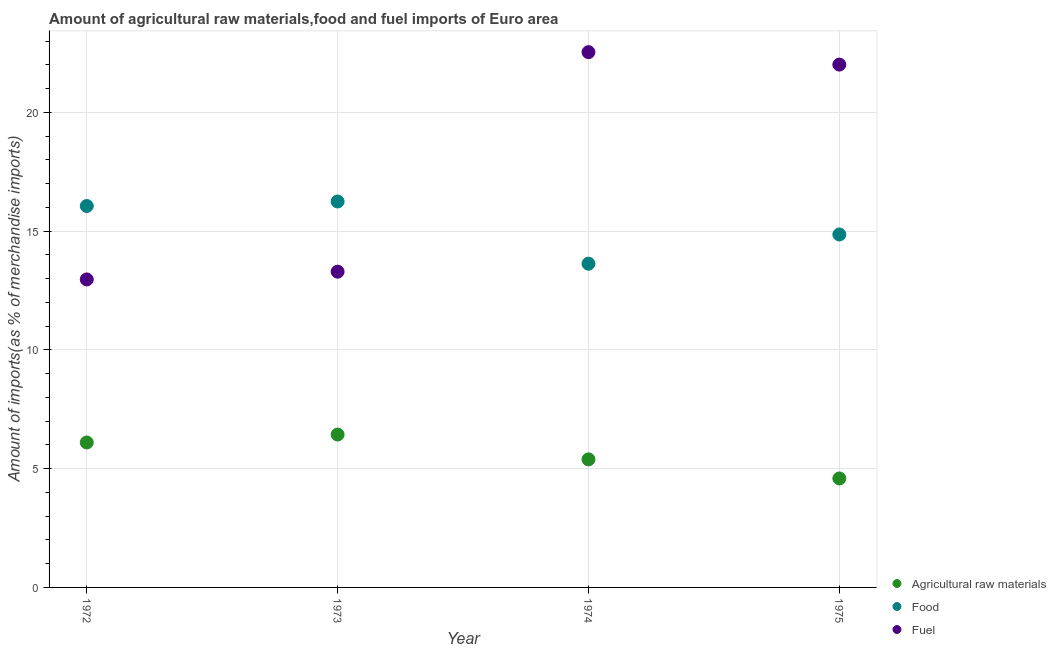How many different coloured dotlines are there?
Make the answer very short. 3. Is the number of dotlines equal to the number of legend labels?
Make the answer very short. Yes. What is the percentage of raw materials imports in 1973?
Provide a short and direct response. 6.44. Across all years, what is the maximum percentage of food imports?
Offer a terse response. 16.25. Across all years, what is the minimum percentage of raw materials imports?
Provide a succinct answer. 4.59. In which year was the percentage of food imports maximum?
Give a very brief answer. 1973. In which year was the percentage of raw materials imports minimum?
Offer a very short reply. 1975. What is the total percentage of raw materials imports in the graph?
Make the answer very short. 22.51. What is the difference between the percentage of food imports in 1972 and that in 1973?
Your answer should be very brief. -0.19. What is the difference between the percentage of raw materials imports in 1975 and the percentage of food imports in 1973?
Your answer should be compact. -11.66. What is the average percentage of food imports per year?
Keep it short and to the point. 15.2. In the year 1972, what is the difference between the percentage of food imports and percentage of fuel imports?
Provide a short and direct response. 3.09. In how many years, is the percentage of raw materials imports greater than 19 %?
Keep it short and to the point. 0. What is the ratio of the percentage of raw materials imports in 1972 to that in 1973?
Offer a terse response. 0.95. Is the percentage of raw materials imports in 1972 less than that in 1974?
Your answer should be very brief. No. Is the difference between the percentage of raw materials imports in 1972 and 1975 greater than the difference between the percentage of food imports in 1972 and 1975?
Your answer should be very brief. Yes. What is the difference between the highest and the second highest percentage of fuel imports?
Give a very brief answer. 0.52. What is the difference between the highest and the lowest percentage of food imports?
Keep it short and to the point. 2.62. Does the percentage of food imports monotonically increase over the years?
Your answer should be compact. No. Is the percentage of raw materials imports strictly greater than the percentage of food imports over the years?
Give a very brief answer. No. Is the percentage of raw materials imports strictly less than the percentage of fuel imports over the years?
Offer a terse response. Yes. Are the values on the major ticks of Y-axis written in scientific E-notation?
Offer a terse response. No. What is the title of the graph?
Keep it short and to the point. Amount of agricultural raw materials,food and fuel imports of Euro area. Does "Coal" appear as one of the legend labels in the graph?
Ensure brevity in your answer.  No. What is the label or title of the X-axis?
Make the answer very short. Year. What is the label or title of the Y-axis?
Provide a short and direct response. Amount of imports(as % of merchandise imports). What is the Amount of imports(as % of merchandise imports) of Agricultural raw materials in 1972?
Provide a succinct answer. 6.1. What is the Amount of imports(as % of merchandise imports) in Food in 1972?
Your answer should be compact. 16.05. What is the Amount of imports(as % of merchandise imports) of Fuel in 1972?
Offer a very short reply. 12.96. What is the Amount of imports(as % of merchandise imports) of Agricultural raw materials in 1973?
Ensure brevity in your answer.  6.44. What is the Amount of imports(as % of merchandise imports) in Food in 1973?
Give a very brief answer. 16.25. What is the Amount of imports(as % of merchandise imports) of Fuel in 1973?
Your response must be concise. 13.29. What is the Amount of imports(as % of merchandise imports) in Agricultural raw materials in 1974?
Provide a short and direct response. 5.39. What is the Amount of imports(as % of merchandise imports) of Food in 1974?
Your answer should be compact. 13.63. What is the Amount of imports(as % of merchandise imports) of Fuel in 1974?
Make the answer very short. 22.53. What is the Amount of imports(as % of merchandise imports) in Agricultural raw materials in 1975?
Offer a very short reply. 4.59. What is the Amount of imports(as % of merchandise imports) in Food in 1975?
Your answer should be compact. 14.86. What is the Amount of imports(as % of merchandise imports) in Fuel in 1975?
Your answer should be compact. 22.01. Across all years, what is the maximum Amount of imports(as % of merchandise imports) of Agricultural raw materials?
Your answer should be very brief. 6.44. Across all years, what is the maximum Amount of imports(as % of merchandise imports) in Food?
Your answer should be compact. 16.25. Across all years, what is the maximum Amount of imports(as % of merchandise imports) in Fuel?
Keep it short and to the point. 22.53. Across all years, what is the minimum Amount of imports(as % of merchandise imports) of Agricultural raw materials?
Give a very brief answer. 4.59. Across all years, what is the minimum Amount of imports(as % of merchandise imports) in Food?
Provide a short and direct response. 13.63. Across all years, what is the minimum Amount of imports(as % of merchandise imports) of Fuel?
Your answer should be very brief. 12.96. What is the total Amount of imports(as % of merchandise imports) of Agricultural raw materials in the graph?
Your answer should be compact. 22.51. What is the total Amount of imports(as % of merchandise imports) in Food in the graph?
Your answer should be compact. 60.78. What is the total Amount of imports(as % of merchandise imports) of Fuel in the graph?
Make the answer very short. 70.79. What is the difference between the Amount of imports(as % of merchandise imports) in Agricultural raw materials in 1972 and that in 1973?
Make the answer very short. -0.33. What is the difference between the Amount of imports(as % of merchandise imports) of Food in 1972 and that in 1973?
Give a very brief answer. -0.19. What is the difference between the Amount of imports(as % of merchandise imports) of Fuel in 1972 and that in 1973?
Your response must be concise. -0.33. What is the difference between the Amount of imports(as % of merchandise imports) of Agricultural raw materials in 1972 and that in 1974?
Offer a very short reply. 0.71. What is the difference between the Amount of imports(as % of merchandise imports) of Food in 1972 and that in 1974?
Offer a very short reply. 2.43. What is the difference between the Amount of imports(as % of merchandise imports) in Fuel in 1972 and that in 1974?
Your answer should be compact. -9.57. What is the difference between the Amount of imports(as % of merchandise imports) in Agricultural raw materials in 1972 and that in 1975?
Make the answer very short. 1.51. What is the difference between the Amount of imports(as % of merchandise imports) in Food in 1972 and that in 1975?
Offer a terse response. 1.2. What is the difference between the Amount of imports(as % of merchandise imports) in Fuel in 1972 and that in 1975?
Make the answer very short. -9.04. What is the difference between the Amount of imports(as % of merchandise imports) of Agricultural raw materials in 1973 and that in 1974?
Give a very brief answer. 1.04. What is the difference between the Amount of imports(as % of merchandise imports) of Food in 1973 and that in 1974?
Make the answer very short. 2.62. What is the difference between the Amount of imports(as % of merchandise imports) of Fuel in 1973 and that in 1974?
Make the answer very short. -9.24. What is the difference between the Amount of imports(as % of merchandise imports) in Agricultural raw materials in 1973 and that in 1975?
Offer a very short reply. 1.85. What is the difference between the Amount of imports(as % of merchandise imports) in Food in 1973 and that in 1975?
Provide a short and direct response. 1.39. What is the difference between the Amount of imports(as % of merchandise imports) of Fuel in 1973 and that in 1975?
Your response must be concise. -8.72. What is the difference between the Amount of imports(as % of merchandise imports) of Agricultural raw materials in 1974 and that in 1975?
Make the answer very short. 0.8. What is the difference between the Amount of imports(as % of merchandise imports) in Food in 1974 and that in 1975?
Give a very brief answer. -1.23. What is the difference between the Amount of imports(as % of merchandise imports) of Fuel in 1974 and that in 1975?
Give a very brief answer. 0.52. What is the difference between the Amount of imports(as % of merchandise imports) in Agricultural raw materials in 1972 and the Amount of imports(as % of merchandise imports) in Food in 1973?
Keep it short and to the point. -10.14. What is the difference between the Amount of imports(as % of merchandise imports) in Agricultural raw materials in 1972 and the Amount of imports(as % of merchandise imports) in Fuel in 1973?
Ensure brevity in your answer.  -7.19. What is the difference between the Amount of imports(as % of merchandise imports) of Food in 1972 and the Amount of imports(as % of merchandise imports) of Fuel in 1973?
Your answer should be very brief. 2.76. What is the difference between the Amount of imports(as % of merchandise imports) in Agricultural raw materials in 1972 and the Amount of imports(as % of merchandise imports) in Food in 1974?
Provide a succinct answer. -7.52. What is the difference between the Amount of imports(as % of merchandise imports) in Agricultural raw materials in 1972 and the Amount of imports(as % of merchandise imports) in Fuel in 1974?
Your answer should be very brief. -16.43. What is the difference between the Amount of imports(as % of merchandise imports) in Food in 1972 and the Amount of imports(as % of merchandise imports) in Fuel in 1974?
Offer a very short reply. -6.48. What is the difference between the Amount of imports(as % of merchandise imports) of Agricultural raw materials in 1972 and the Amount of imports(as % of merchandise imports) of Food in 1975?
Your answer should be very brief. -8.76. What is the difference between the Amount of imports(as % of merchandise imports) of Agricultural raw materials in 1972 and the Amount of imports(as % of merchandise imports) of Fuel in 1975?
Give a very brief answer. -15.91. What is the difference between the Amount of imports(as % of merchandise imports) in Food in 1972 and the Amount of imports(as % of merchandise imports) in Fuel in 1975?
Give a very brief answer. -5.95. What is the difference between the Amount of imports(as % of merchandise imports) in Agricultural raw materials in 1973 and the Amount of imports(as % of merchandise imports) in Food in 1974?
Your answer should be compact. -7.19. What is the difference between the Amount of imports(as % of merchandise imports) in Agricultural raw materials in 1973 and the Amount of imports(as % of merchandise imports) in Fuel in 1974?
Give a very brief answer. -16.1. What is the difference between the Amount of imports(as % of merchandise imports) of Food in 1973 and the Amount of imports(as % of merchandise imports) of Fuel in 1974?
Offer a very short reply. -6.29. What is the difference between the Amount of imports(as % of merchandise imports) of Agricultural raw materials in 1973 and the Amount of imports(as % of merchandise imports) of Food in 1975?
Give a very brief answer. -8.42. What is the difference between the Amount of imports(as % of merchandise imports) in Agricultural raw materials in 1973 and the Amount of imports(as % of merchandise imports) in Fuel in 1975?
Your answer should be very brief. -15.57. What is the difference between the Amount of imports(as % of merchandise imports) in Food in 1973 and the Amount of imports(as % of merchandise imports) in Fuel in 1975?
Provide a succinct answer. -5.76. What is the difference between the Amount of imports(as % of merchandise imports) of Agricultural raw materials in 1974 and the Amount of imports(as % of merchandise imports) of Food in 1975?
Provide a short and direct response. -9.47. What is the difference between the Amount of imports(as % of merchandise imports) in Agricultural raw materials in 1974 and the Amount of imports(as % of merchandise imports) in Fuel in 1975?
Offer a very short reply. -16.62. What is the difference between the Amount of imports(as % of merchandise imports) in Food in 1974 and the Amount of imports(as % of merchandise imports) in Fuel in 1975?
Provide a short and direct response. -8.38. What is the average Amount of imports(as % of merchandise imports) of Agricultural raw materials per year?
Offer a terse response. 5.63. What is the average Amount of imports(as % of merchandise imports) of Food per year?
Offer a terse response. 15.2. What is the average Amount of imports(as % of merchandise imports) of Fuel per year?
Make the answer very short. 17.7. In the year 1972, what is the difference between the Amount of imports(as % of merchandise imports) in Agricultural raw materials and Amount of imports(as % of merchandise imports) in Food?
Provide a succinct answer. -9.95. In the year 1972, what is the difference between the Amount of imports(as % of merchandise imports) in Agricultural raw materials and Amount of imports(as % of merchandise imports) in Fuel?
Ensure brevity in your answer.  -6.86. In the year 1972, what is the difference between the Amount of imports(as % of merchandise imports) in Food and Amount of imports(as % of merchandise imports) in Fuel?
Provide a succinct answer. 3.09. In the year 1973, what is the difference between the Amount of imports(as % of merchandise imports) in Agricultural raw materials and Amount of imports(as % of merchandise imports) in Food?
Your response must be concise. -9.81. In the year 1973, what is the difference between the Amount of imports(as % of merchandise imports) of Agricultural raw materials and Amount of imports(as % of merchandise imports) of Fuel?
Offer a very short reply. -6.86. In the year 1973, what is the difference between the Amount of imports(as % of merchandise imports) of Food and Amount of imports(as % of merchandise imports) of Fuel?
Provide a succinct answer. 2.95. In the year 1974, what is the difference between the Amount of imports(as % of merchandise imports) of Agricultural raw materials and Amount of imports(as % of merchandise imports) of Food?
Keep it short and to the point. -8.24. In the year 1974, what is the difference between the Amount of imports(as % of merchandise imports) of Agricultural raw materials and Amount of imports(as % of merchandise imports) of Fuel?
Ensure brevity in your answer.  -17.14. In the year 1974, what is the difference between the Amount of imports(as % of merchandise imports) of Food and Amount of imports(as % of merchandise imports) of Fuel?
Provide a succinct answer. -8.91. In the year 1975, what is the difference between the Amount of imports(as % of merchandise imports) of Agricultural raw materials and Amount of imports(as % of merchandise imports) of Food?
Your answer should be compact. -10.27. In the year 1975, what is the difference between the Amount of imports(as % of merchandise imports) of Agricultural raw materials and Amount of imports(as % of merchandise imports) of Fuel?
Your answer should be compact. -17.42. In the year 1975, what is the difference between the Amount of imports(as % of merchandise imports) in Food and Amount of imports(as % of merchandise imports) in Fuel?
Make the answer very short. -7.15. What is the ratio of the Amount of imports(as % of merchandise imports) of Agricultural raw materials in 1972 to that in 1973?
Provide a short and direct response. 0.95. What is the ratio of the Amount of imports(as % of merchandise imports) in Food in 1972 to that in 1973?
Ensure brevity in your answer.  0.99. What is the ratio of the Amount of imports(as % of merchandise imports) of Fuel in 1972 to that in 1973?
Offer a terse response. 0.98. What is the ratio of the Amount of imports(as % of merchandise imports) of Agricultural raw materials in 1972 to that in 1974?
Keep it short and to the point. 1.13. What is the ratio of the Amount of imports(as % of merchandise imports) of Food in 1972 to that in 1974?
Ensure brevity in your answer.  1.18. What is the ratio of the Amount of imports(as % of merchandise imports) of Fuel in 1972 to that in 1974?
Keep it short and to the point. 0.58. What is the ratio of the Amount of imports(as % of merchandise imports) of Agricultural raw materials in 1972 to that in 1975?
Provide a short and direct response. 1.33. What is the ratio of the Amount of imports(as % of merchandise imports) in Food in 1972 to that in 1975?
Your answer should be very brief. 1.08. What is the ratio of the Amount of imports(as % of merchandise imports) of Fuel in 1972 to that in 1975?
Offer a very short reply. 0.59. What is the ratio of the Amount of imports(as % of merchandise imports) in Agricultural raw materials in 1973 to that in 1974?
Provide a succinct answer. 1.19. What is the ratio of the Amount of imports(as % of merchandise imports) of Food in 1973 to that in 1974?
Offer a very short reply. 1.19. What is the ratio of the Amount of imports(as % of merchandise imports) in Fuel in 1973 to that in 1974?
Make the answer very short. 0.59. What is the ratio of the Amount of imports(as % of merchandise imports) in Agricultural raw materials in 1973 to that in 1975?
Your answer should be compact. 1.4. What is the ratio of the Amount of imports(as % of merchandise imports) in Food in 1973 to that in 1975?
Make the answer very short. 1.09. What is the ratio of the Amount of imports(as % of merchandise imports) of Fuel in 1973 to that in 1975?
Ensure brevity in your answer.  0.6. What is the ratio of the Amount of imports(as % of merchandise imports) in Agricultural raw materials in 1974 to that in 1975?
Keep it short and to the point. 1.18. What is the ratio of the Amount of imports(as % of merchandise imports) of Food in 1974 to that in 1975?
Ensure brevity in your answer.  0.92. What is the ratio of the Amount of imports(as % of merchandise imports) of Fuel in 1974 to that in 1975?
Provide a short and direct response. 1.02. What is the difference between the highest and the second highest Amount of imports(as % of merchandise imports) of Agricultural raw materials?
Offer a very short reply. 0.33. What is the difference between the highest and the second highest Amount of imports(as % of merchandise imports) of Food?
Give a very brief answer. 0.19. What is the difference between the highest and the second highest Amount of imports(as % of merchandise imports) in Fuel?
Your response must be concise. 0.52. What is the difference between the highest and the lowest Amount of imports(as % of merchandise imports) in Agricultural raw materials?
Provide a short and direct response. 1.85. What is the difference between the highest and the lowest Amount of imports(as % of merchandise imports) in Food?
Ensure brevity in your answer.  2.62. What is the difference between the highest and the lowest Amount of imports(as % of merchandise imports) of Fuel?
Offer a terse response. 9.57. 